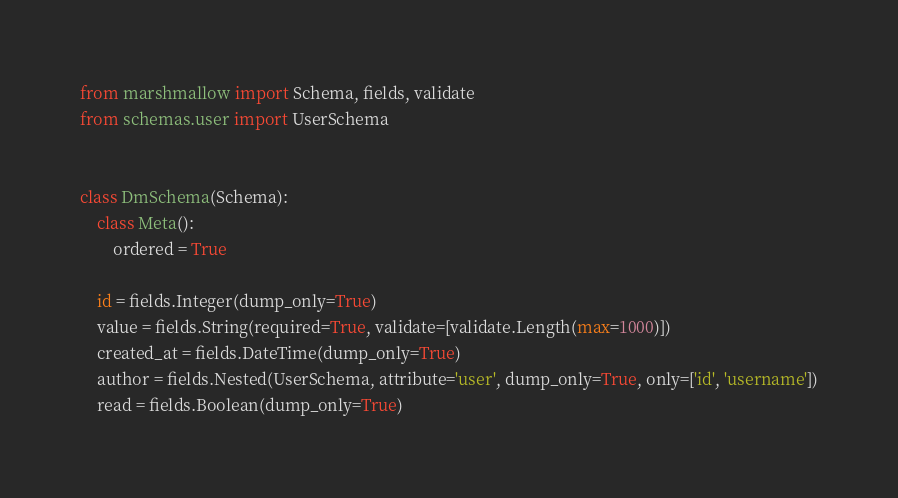Convert code to text. <code><loc_0><loc_0><loc_500><loc_500><_Python_>from marshmallow import Schema, fields, validate
from schemas.user import UserSchema


class DmSchema(Schema):
    class Meta():
        ordered = True

    id = fields.Integer(dump_only=True)
    value = fields.String(required=True, validate=[validate.Length(max=1000)])
    created_at = fields.DateTime(dump_only=True)
    author = fields.Nested(UserSchema, attribute='user', dump_only=True, only=['id', 'username'])
    read = fields.Boolean(dump_only=True)

</code> 